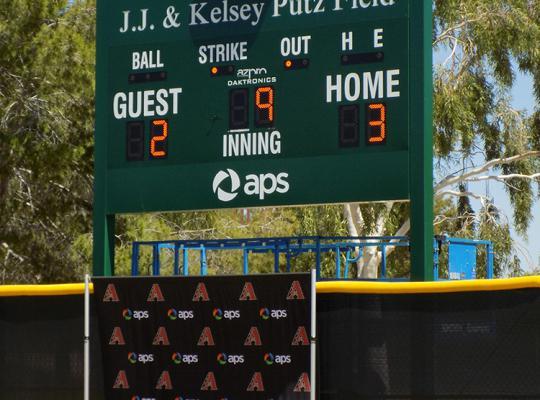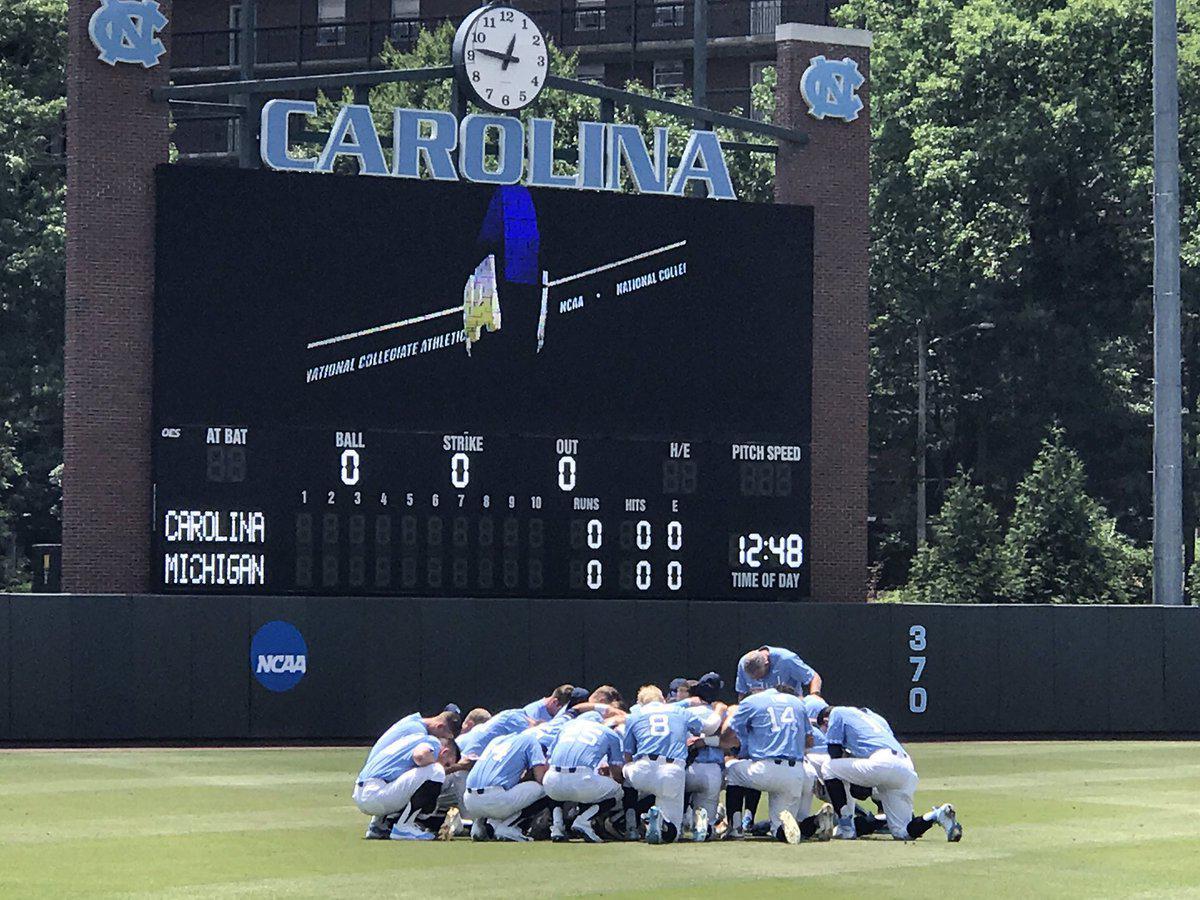The first image is the image on the left, the second image is the image on the right. For the images shown, is this caption "One of the images shows a scoreboard with no people around and the other image shows a scoreboard with a team of players on the field." true? Answer yes or no. Yes. 